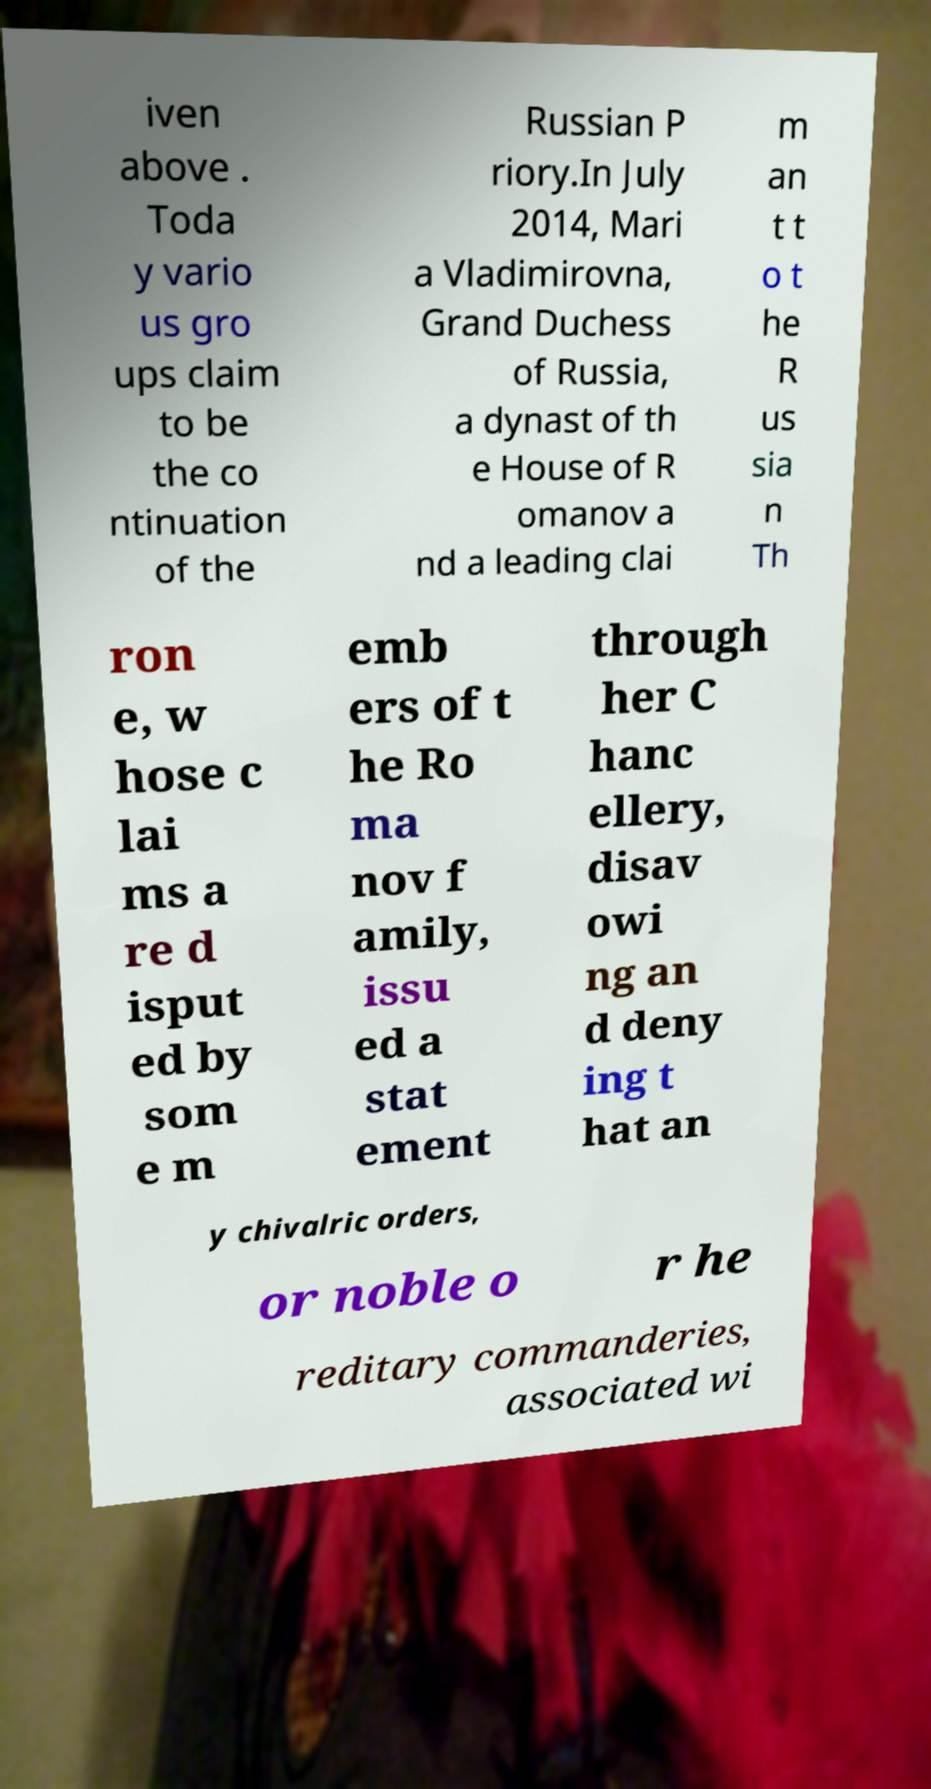Could you assist in decoding the text presented in this image and type it out clearly? iven above . Toda y vario us gro ups claim to be the co ntinuation of the Russian P riory.In July 2014, Mari a Vladimirovna, Grand Duchess of Russia, a dynast of th e House of R omanov a nd a leading clai m an t t o t he R us sia n Th ron e, w hose c lai ms a re d isput ed by som e m emb ers of t he Ro ma nov f amily, issu ed a stat ement through her C hanc ellery, disav owi ng an d deny ing t hat an y chivalric orders, or noble o r he reditary commanderies, associated wi 